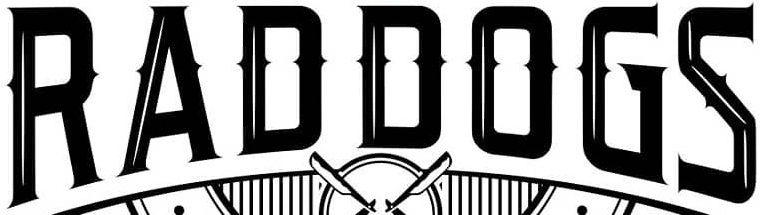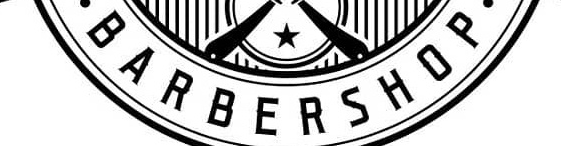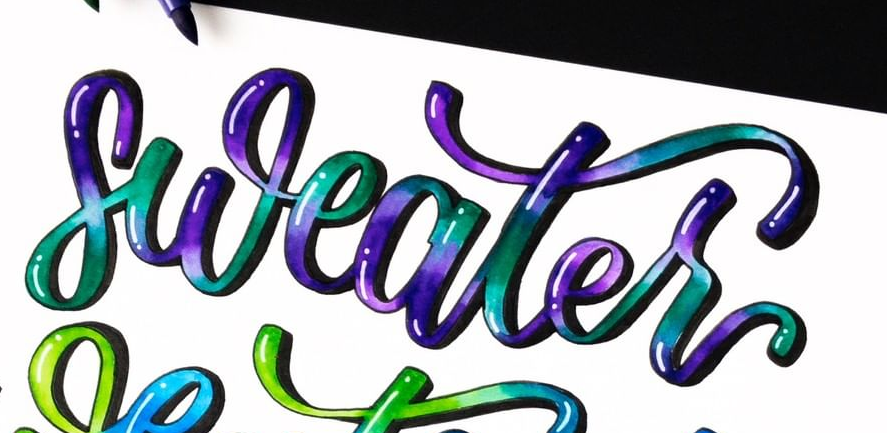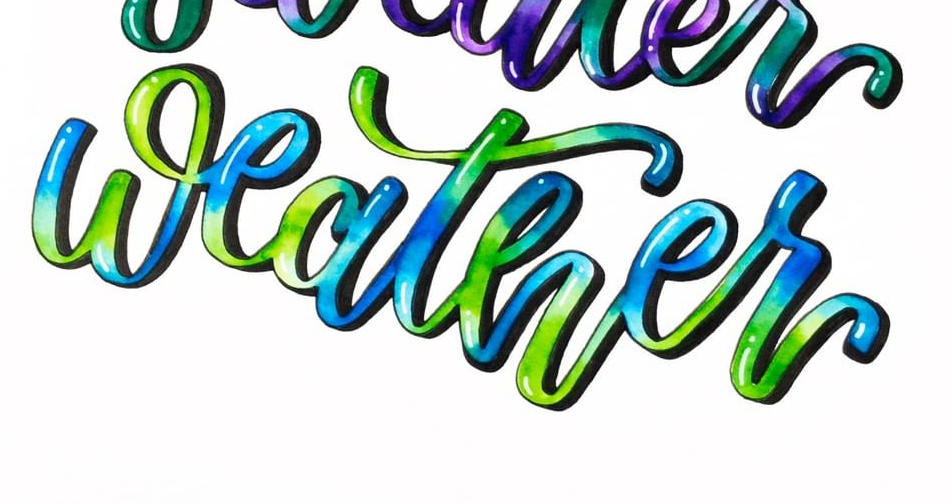Read the text from these images in sequence, separated by a semicolon. RADDOGS; BARBERSHOP; sweater; weather 